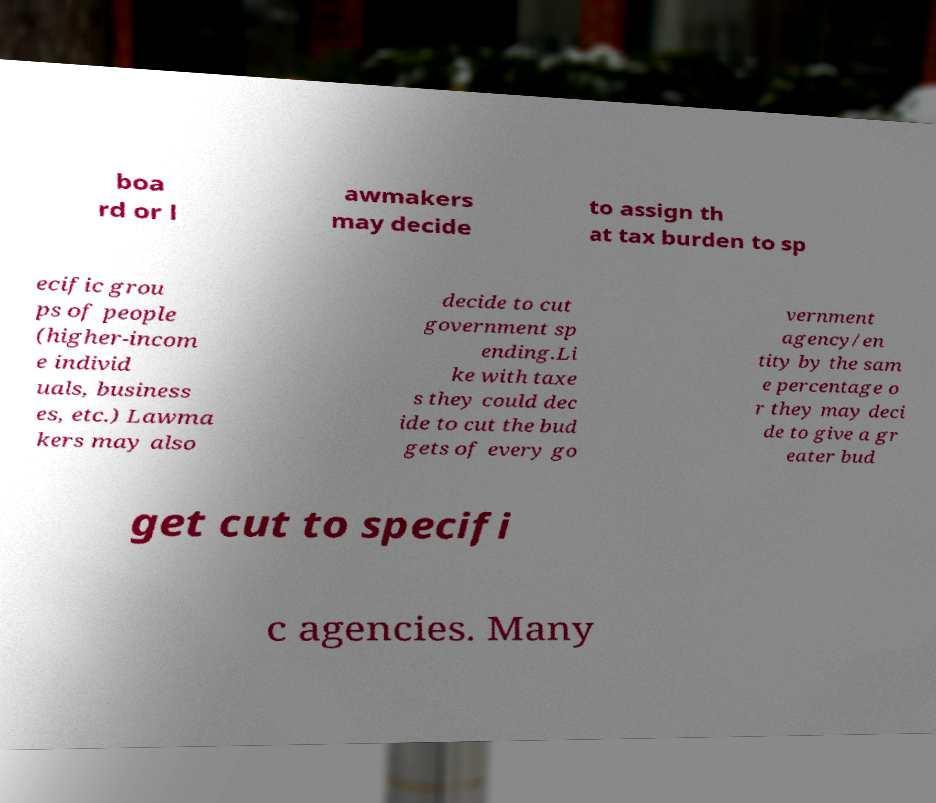For documentation purposes, I need the text within this image transcribed. Could you provide that? boa rd or l awmakers may decide to assign th at tax burden to sp ecific grou ps of people (higher-incom e individ uals, business es, etc.) Lawma kers may also decide to cut government sp ending.Li ke with taxe s they could dec ide to cut the bud gets of every go vernment agency/en tity by the sam e percentage o r they may deci de to give a gr eater bud get cut to specifi c agencies. Many 